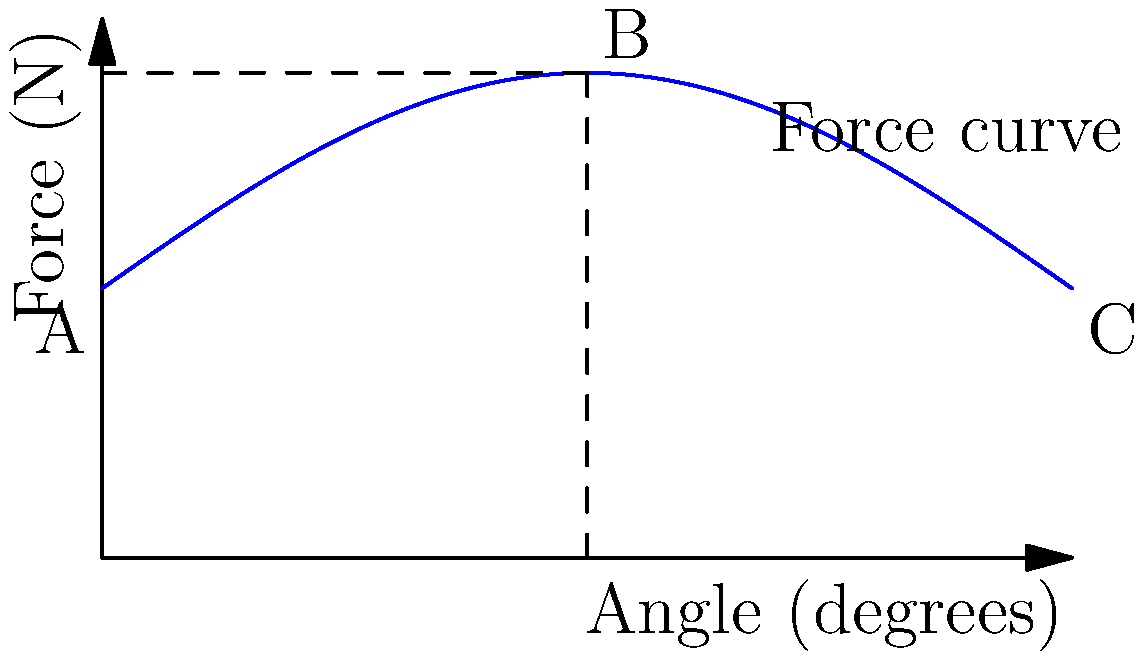In the context of bell-ringing in church towers, the graph shows the relationship between the angle of the bell and the force exerted on the ringer's arms and shoulders. At which point (A, B, or C) does the ringer experience the greatest biomechanical stress, and how does this relate to the historical practice of bell-ringing in Protestant churches? To answer this question, we need to analyze the graph and consider the historical context of bell-ringing in Protestant churches:

1. The x-axis represents the angle of the bell, ranging from 0° to 180°.
2. The y-axis represents the force exerted on the ringer's arms and shoulders in Newtons (N).
3. The blue curve shows how the force changes as the bell rotates through its cycle.

Analyzing the points:
A (0°): Initial position, moderate force (50 N)
B (90°): Midpoint of rotation, maximum force (90 N)
C (180°): Full rotation, moderate force (50 N)

The ringer experiences the greatest biomechanical stress at point B (90°), where the force reaches its maximum of 90 N. This occurs when the bell is horizontal, requiring the most effort to control its momentum.

Historical context:
1. Bell-ringing became particularly important in Protestant churches after the Reformation, as it was seen as a way to call the community to worship without the need for elaborate Catholic rituals.
2. The development of change ringing in England during the 16th and 17th centuries coincided with the spread of Protestantism.
3. The physical demands of bell-ringing, as illustrated by the force curve, reflect the Protestant emphasis on active participation in worship and community involvement.
4. The regular, rhythmic nature of change ringing aligns with the Protestant focus on order and simplicity in worship practices.

The biomechanical stress experienced by ringers during this activity underscores the physical commitment required in this form of Protestant expression, contrasting with more passive forms of worship in the Catholic tradition.
Answer: Point B (90°), reflecting Protestant emphasis on active worship participation. 